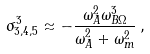<formula> <loc_0><loc_0><loc_500><loc_500>\sigma _ { 3 , 4 , 5 } ^ { 3 } \approx - \frac { \omega _ { A } ^ { 2 } \omega _ { B \Omega } ^ { 3 } } { \omega _ { A } ^ { 2 } + \omega _ { m } ^ { 2 } } \, , \,</formula> 